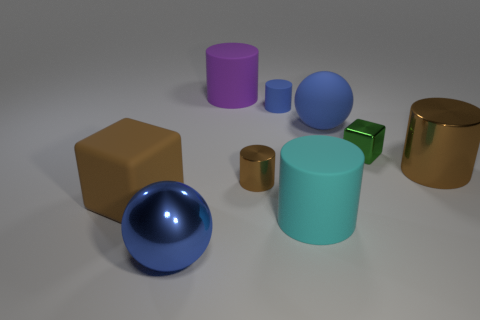Subtract all cyan cylinders. How many cylinders are left? 4 Subtract all red cylinders. Subtract all cyan spheres. How many cylinders are left? 5 Add 1 blue metal cylinders. How many objects exist? 10 Subtract all balls. How many objects are left? 7 Subtract 1 cyan cylinders. How many objects are left? 8 Subtract all blue matte blocks. Subtract all big brown matte cubes. How many objects are left? 8 Add 7 large cyan things. How many large cyan things are left? 8 Add 9 small purple blocks. How many small purple blocks exist? 9 